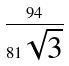<formula> <loc_0><loc_0><loc_500><loc_500>\frac { 9 4 } { 8 1 \sqrt { 3 } }</formula> 